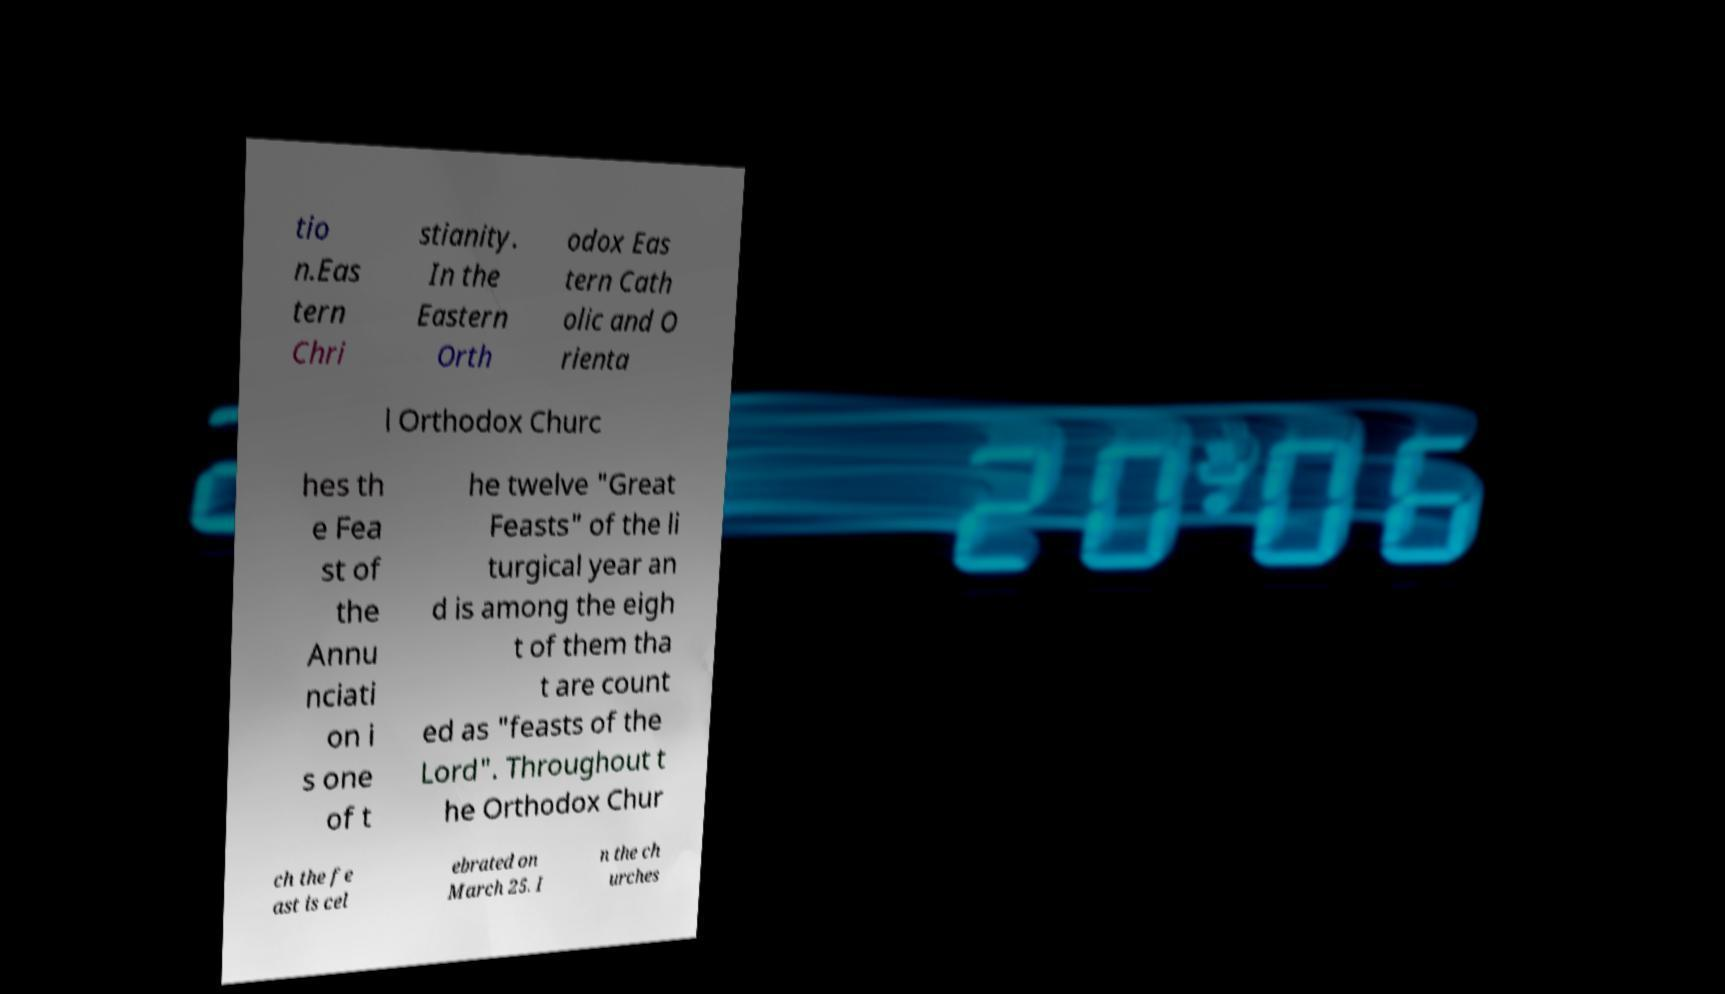For documentation purposes, I need the text within this image transcribed. Could you provide that? tio n.Eas tern Chri stianity. In the Eastern Orth odox Eas tern Cath olic and O rienta l Orthodox Churc hes th e Fea st of the Annu nciati on i s one of t he twelve "Great Feasts" of the li turgical year an d is among the eigh t of them tha t are count ed as "feasts of the Lord". Throughout t he Orthodox Chur ch the fe ast is cel ebrated on March 25. I n the ch urches 